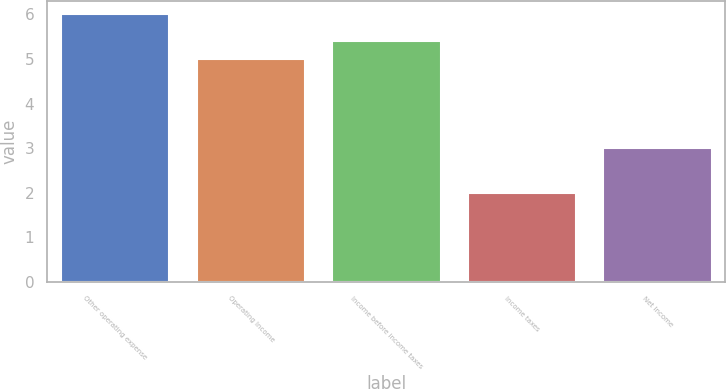<chart> <loc_0><loc_0><loc_500><loc_500><bar_chart><fcel>Other operating expense<fcel>Operating Income<fcel>Income before income taxes<fcel>Income taxes<fcel>Net Income<nl><fcel>6<fcel>5<fcel>5.4<fcel>2<fcel>3<nl></chart> 